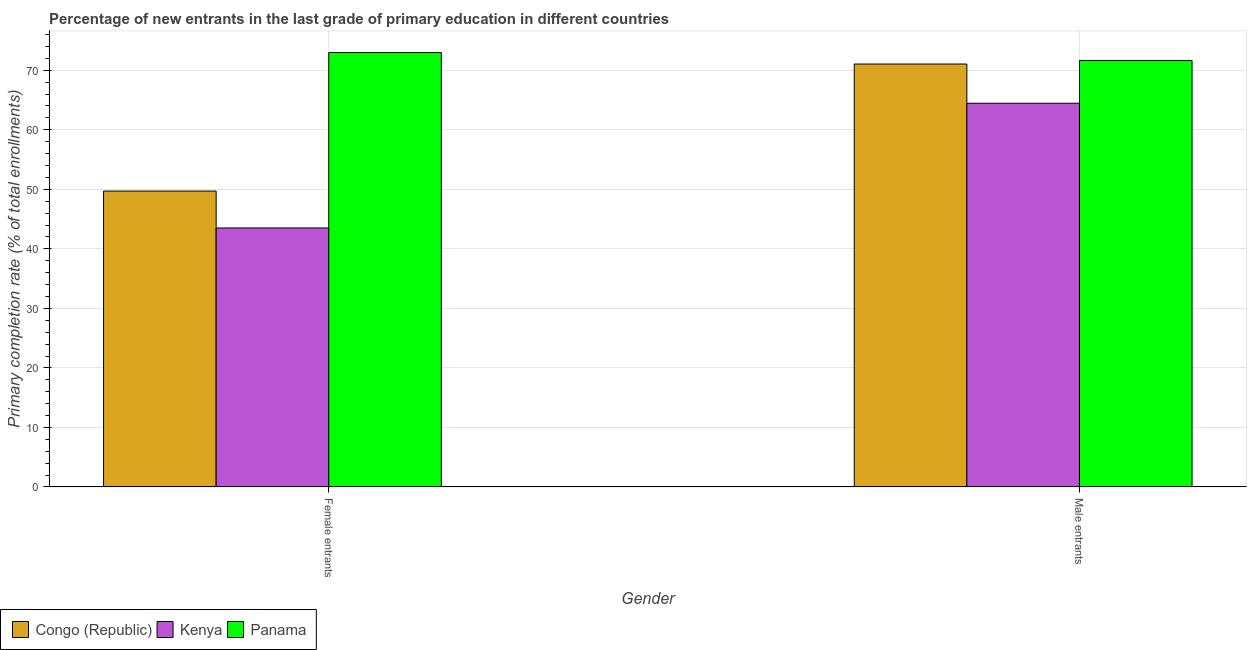How many different coloured bars are there?
Offer a very short reply. 3. How many bars are there on the 1st tick from the left?
Make the answer very short. 3. What is the label of the 1st group of bars from the left?
Offer a terse response. Female entrants. What is the primary completion rate of female entrants in Panama?
Offer a very short reply. 72.97. Across all countries, what is the maximum primary completion rate of female entrants?
Your answer should be very brief. 72.97. Across all countries, what is the minimum primary completion rate of female entrants?
Keep it short and to the point. 43.51. In which country was the primary completion rate of male entrants maximum?
Offer a terse response. Panama. In which country was the primary completion rate of male entrants minimum?
Keep it short and to the point. Kenya. What is the total primary completion rate of female entrants in the graph?
Give a very brief answer. 166.18. What is the difference between the primary completion rate of female entrants in Congo (Republic) and that in Panama?
Your response must be concise. -23.27. What is the difference between the primary completion rate of male entrants in Congo (Republic) and the primary completion rate of female entrants in Panama?
Provide a succinct answer. -1.93. What is the average primary completion rate of female entrants per country?
Your response must be concise. 55.39. What is the difference between the primary completion rate of male entrants and primary completion rate of female entrants in Kenya?
Your answer should be very brief. 20.95. In how many countries, is the primary completion rate of female entrants greater than 20 %?
Provide a succinct answer. 3. What is the ratio of the primary completion rate of male entrants in Congo (Republic) to that in Kenya?
Your response must be concise. 1.1. Is the primary completion rate of male entrants in Kenya less than that in Congo (Republic)?
Provide a succinct answer. Yes. What does the 1st bar from the left in Female entrants represents?
Provide a succinct answer. Congo (Republic). What does the 2nd bar from the right in Male entrants represents?
Make the answer very short. Kenya. How many bars are there?
Provide a short and direct response. 6. Are all the bars in the graph horizontal?
Your answer should be compact. No. What is the difference between two consecutive major ticks on the Y-axis?
Your answer should be very brief. 10. Are the values on the major ticks of Y-axis written in scientific E-notation?
Your answer should be very brief. No. How many legend labels are there?
Your response must be concise. 3. How are the legend labels stacked?
Give a very brief answer. Horizontal. What is the title of the graph?
Make the answer very short. Percentage of new entrants in the last grade of primary education in different countries. Does "Panama" appear as one of the legend labels in the graph?
Make the answer very short. Yes. What is the label or title of the X-axis?
Your answer should be very brief. Gender. What is the label or title of the Y-axis?
Your answer should be compact. Primary completion rate (% of total enrollments). What is the Primary completion rate (% of total enrollments) of Congo (Republic) in Female entrants?
Provide a succinct answer. 49.7. What is the Primary completion rate (% of total enrollments) in Kenya in Female entrants?
Give a very brief answer. 43.51. What is the Primary completion rate (% of total enrollments) of Panama in Female entrants?
Offer a terse response. 72.97. What is the Primary completion rate (% of total enrollments) in Congo (Republic) in Male entrants?
Offer a very short reply. 71.04. What is the Primary completion rate (% of total enrollments) of Kenya in Male entrants?
Give a very brief answer. 64.46. What is the Primary completion rate (% of total enrollments) of Panama in Male entrants?
Offer a very short reply. 71.64. Across all Gender, what is the maximum Primary completion rate (% of total enrollments) in Congo (Republic)?
Provide a succinct answer. 71.04. Across all Gender, what is the maximum Primary completion rate (% of total enrollments) of Kenya?
Make the answer very short. 64.46. Across all Gender, what is the maximum Primary completion rate (% of total enrollments) of Panama?
Provide a succinct answer. 72.97. Across all Gender, what is the minimum Primary completion rate (% of total enrollments) of Congo (Republic)?
Provide a succinct answer. 49.7. Across all Gender, what is the minimum Primary completion rate (% of total enrollments) in Kenya?
Your response must be concise. 43.51. Across all Gender, what is the minimum Primary completion rate (% of total enrollments) of Panama?
Your response must be concise. 71.64. What is the total Primary completion rate (% of total enrollments) of Congo (Republic) in the graph?
Your answer should be compact. 120.74. What is the total Primary completion rate (% of total enrollments) in Kenya in the graph?
Offer a terse response. 107.97. What is the total Primary completion rate (% of total enrollments) of Panama in the graph?
Keep it short and to the point. 144.61. What is the difference between the Primary completion rate (% of total enrollments) of Congo (Republic) in Female entrants and that in Male entrants?
Keep it short and to the point. -21.34. What is the difference between the Primary completion rate (% of total enrollments) of Kenya in Female entrants and that in Male entrants?
Offer a terse response. -20.95. What is the difference between the Primary completion rate (% of total enrollments) of Panama in Female entrants and that in Male entrants?
Offer a terse response. 1.33. What is the difference between the Primary completion rate (% of total enrollments) of Congo (Republic) in Female entrants and the Primary completion rate (% of total enrollments) of Kenya in Male entrants?
Your answer should be very brief. -14.76. What is the difference between the Primary completion rate (% of total enrollments) of Congo (Republic) in Female entrants and the Primary completion rate (% of total enrollments) of Panama in Male entrants?
Offer a terse response. -21.94. What is the difference between the Primary completion rate (% of total enrollments) of Kenya in Female entrants and the Primary completion rate (% of total enrollments) of Panama in Male entrants?
Your answer should be compact. -28.13. What is the average Primary completion rate (% of total enrollments) of Congo (Republic) per Gender?
Your response must be concise. 60.37. What is the average Primary completion rate (% of total enrollments) of Kenya per Gender?
Provide a succinct answer. 53.98. What is the average Primary completion rate (% of total enrollments) in Panama per Gender?
Make the answer very short. 72.31. What is the difference between the Primary completion rate (% of total enrollments) in Congo (Republic) and Primary completion rate (% of total enrollments) in Kenya in Female entrants?
Make the answer very short. 6.19. What is the difference between the Primary completion rate (% of total enrollments) in Congo (Republic) and Primary completion rate (% of total enrollments) in Panama in Female entrants?
Your answer should be compact. -23.27. What is the difference between the Primary completion rate (% of total enrollments) of Kenya and Primary completion rate (% of total enrollments) of Panama in Female entrants?
Provide a short and direct response. -29.46. What is the difference between the Primary completion rate (% of total enrollments) in Congo (Republic) and Primary completion rate (% of total enrollments) in Kenya in Male entrants?
Offer a terse response. 6.58. What is the difference between the Primary completion rate (% of total enrollments) of Congo (Republic) and Primary completion rate (% of total enrollments) of Panama in Male entrants?
Make the answer very short. -0.6. What is the difference between the Primary completion rate (% of total enrollments) of Kenya and Primary completion rate (% of total enrollments) of Panama in Male entrants?
Your answer should be very brief. -7.18. What is the ratio of the Primary completion rate (% of total enrollments) in Congo (Republic) in Female entrants to that in Male entrants?
Provide a short and direct response. 0.7. What is the ratio of the Primary completion rate (% of total enrollments) in Kenya in Female entrants to that in Male entrants?
Your answer should be compact. 0.68. What is the ratio of the Primary completion rate (% of total enrollments) in Panama in Female entrants to that in Male entrants?
Offer a very short reply. 1.02. What is the difference between the highest and the second highest Primary completion rate (% of total enrollments) of Congo (Republic)?
Your response must be concise. 21.34. What is the difference between the highest and the second highest Primary completion rate (% of total enrollments) of Kenya?
Your response must be concise. 20.95. What is the difference between the highest and the second highest Primary completion rate (% of total enrollments) in Panama?
Give a very brief answer. 1.33. What is the difference between the highest and the lowest Primary completion rate (% of total enrollments) of Congo (Republic)?
Give a very brief answer. 21.34. What is the difference between the highest and the lowest Primary completion rate (% of total enrollments) of Kenya?
Your answer should be compact. 20.95. What is the difference between the highest and the lowest Primary completion rate (% of total enrollments) of Panama?
Keep it short and to the point. 1.33. 